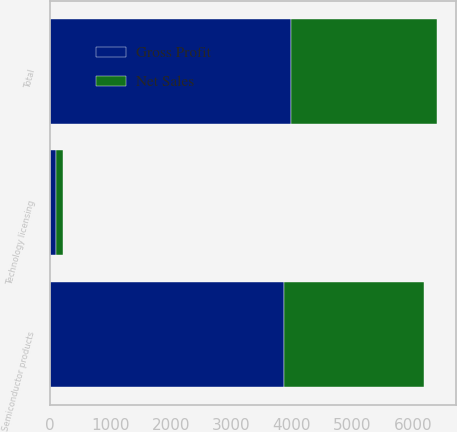Convert chart to OTSL. <chart><loc_0><loc_0><loc_500><loc_500><stacked_bar_chart><ecel><fcel>Semiconductor products<fcel>Technology licensing<fcel>Total<nl><fcel>Gross Profit<fcel>3876<fcel>104.8<fcel>3980.8<nl><fcel>Net Sales<fcel>2315.9<fcel>104.8<fcel>2420.7<nl></chart> 